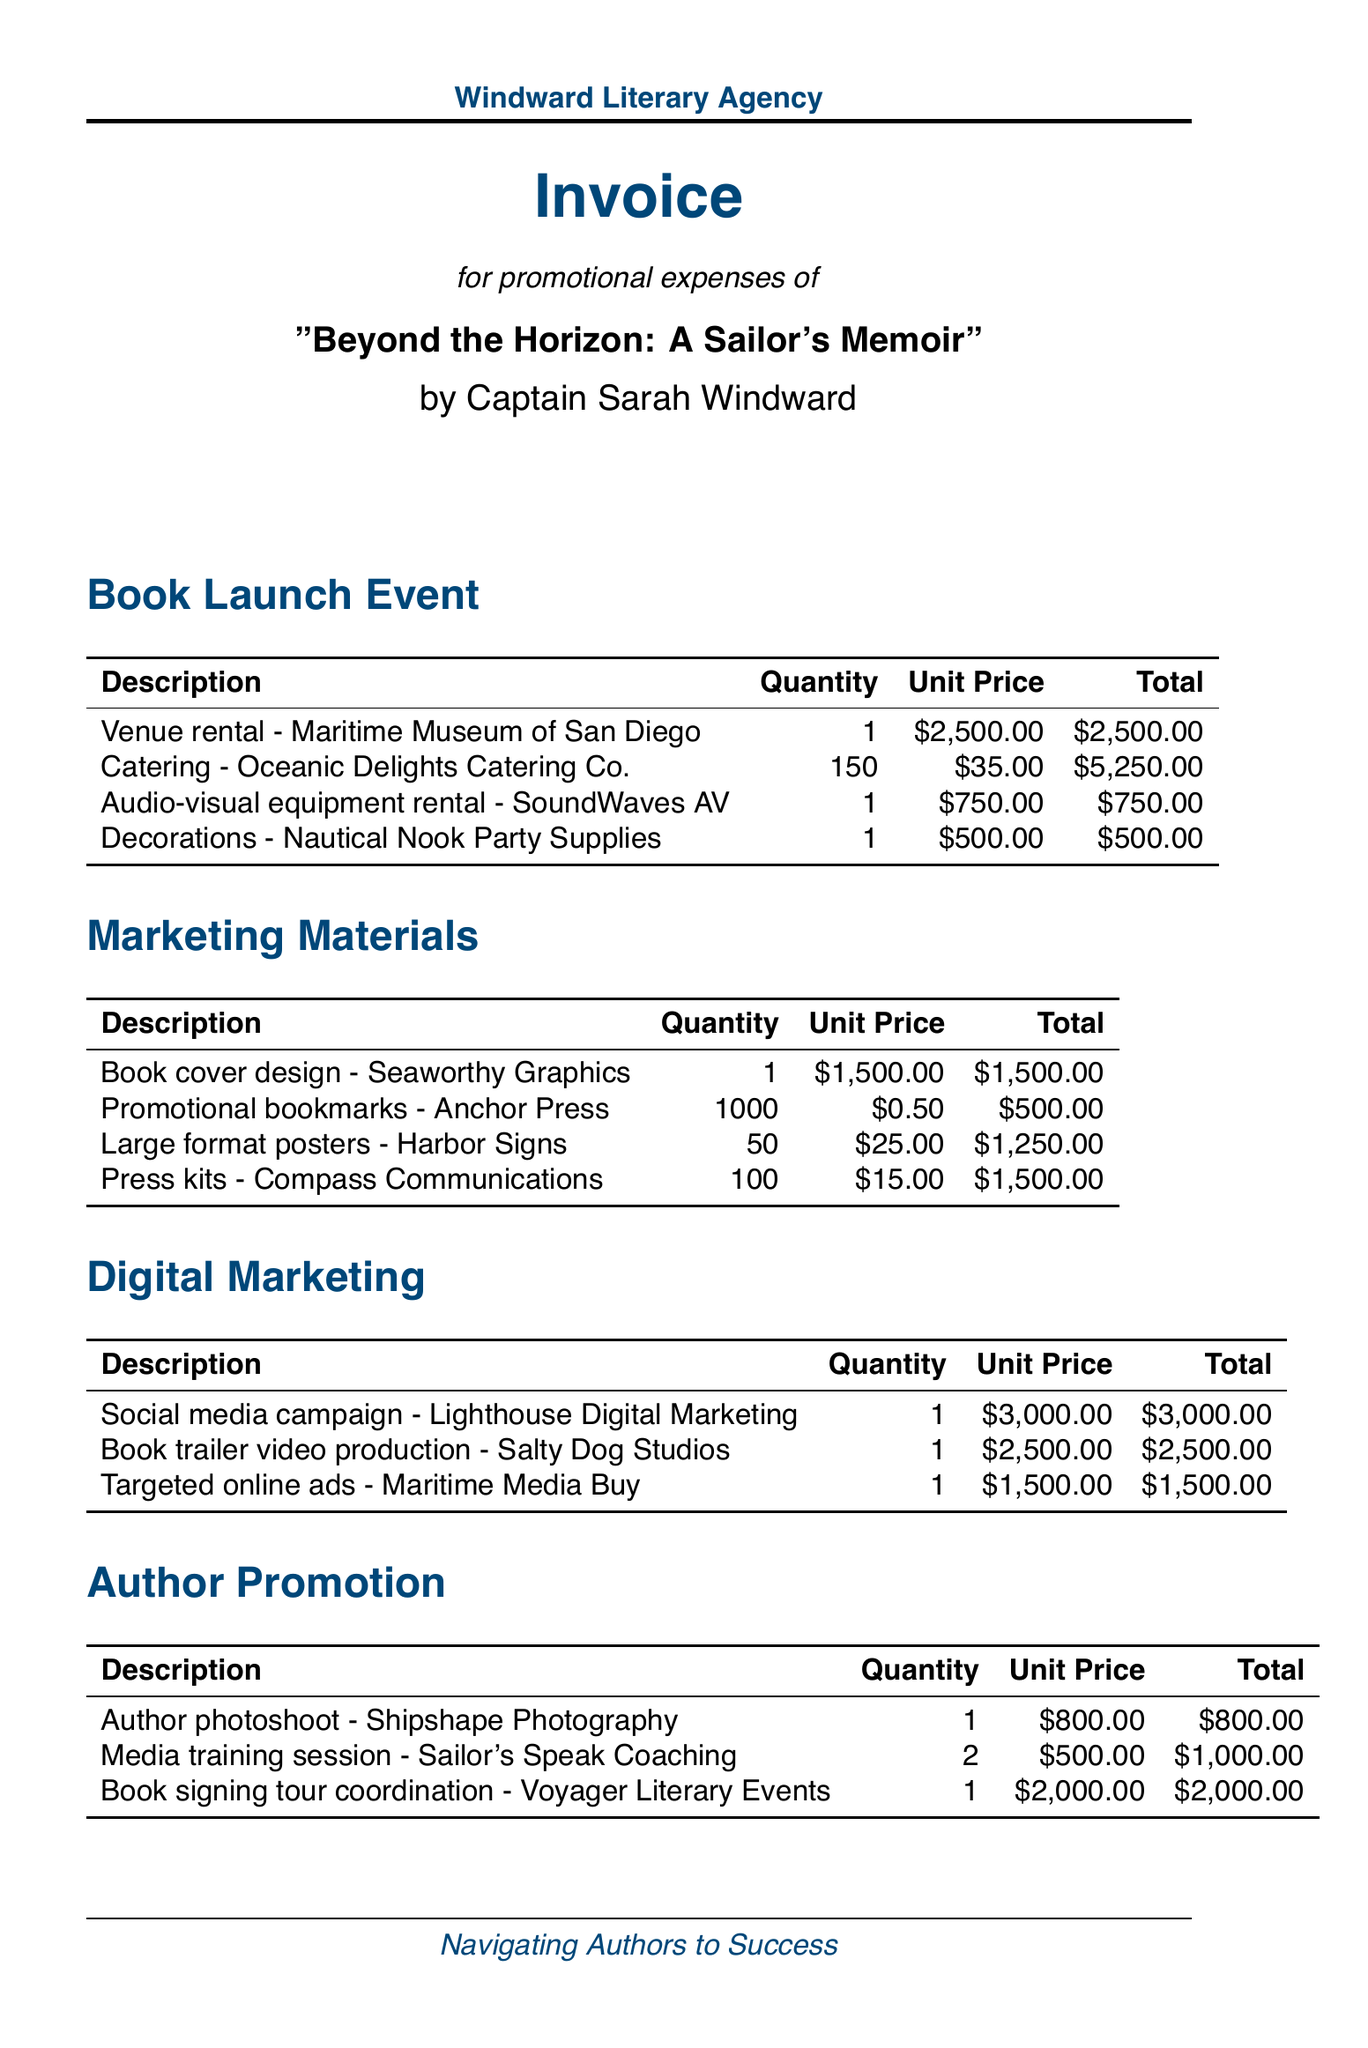What is the total cost of the Book Launch Event? The total cost of the Book Launch Event is obtained by adding the individual costs: $2,500 + $5,250 + $750 + $500 = $9,000.
Answer: $9,000 What is the tax rate applied to the invoice? The tax rate mentioned in the invoice is an important detail that affects the total amount due. It is specified as 8%.
Answer: 8% How many Promotional bookmarks were ordered? The quantity of Promotional bookmarks ordered is a critical detail for inventory and cost assessment. It is listed as 1,000.
Answer: 1,000 What is the unit price for the Author photoshoot? The unit price of the Author photoshoot is a specific cost detail essential for budgeting purposes. It is presented as $800.
Answer: $800 Who provided the catering services for the book launch? Identifying the service providers can be important for accountability and future planning. The catering service for the event is Oceanic Delights Catering Co.
Answer: Oceanic Delights Catering Co What is the subtotal of all promotional expenses? The subtotal provides a summary of costs before tax and is crucial for understanding the financials of the project. It is given as $24,550.
Answer: $24,550 How many media training sessions were conducted? Knowing the quantity of services rendered aids in evaluating overall expenses incurred. The invoice states that 2 media training sessions were conducted.
Answer: 2 What are the payment terms outlined in the invoice? Payment terms are crucial for financial planning and compliance. They are specified as Net 30.
Answer: Net 30 What is the total amount due on the invoice? The total amount due includes all expenses after tax, which is vital for financial reconciliation. It is listed as $26,514.
Answer: $26,514 